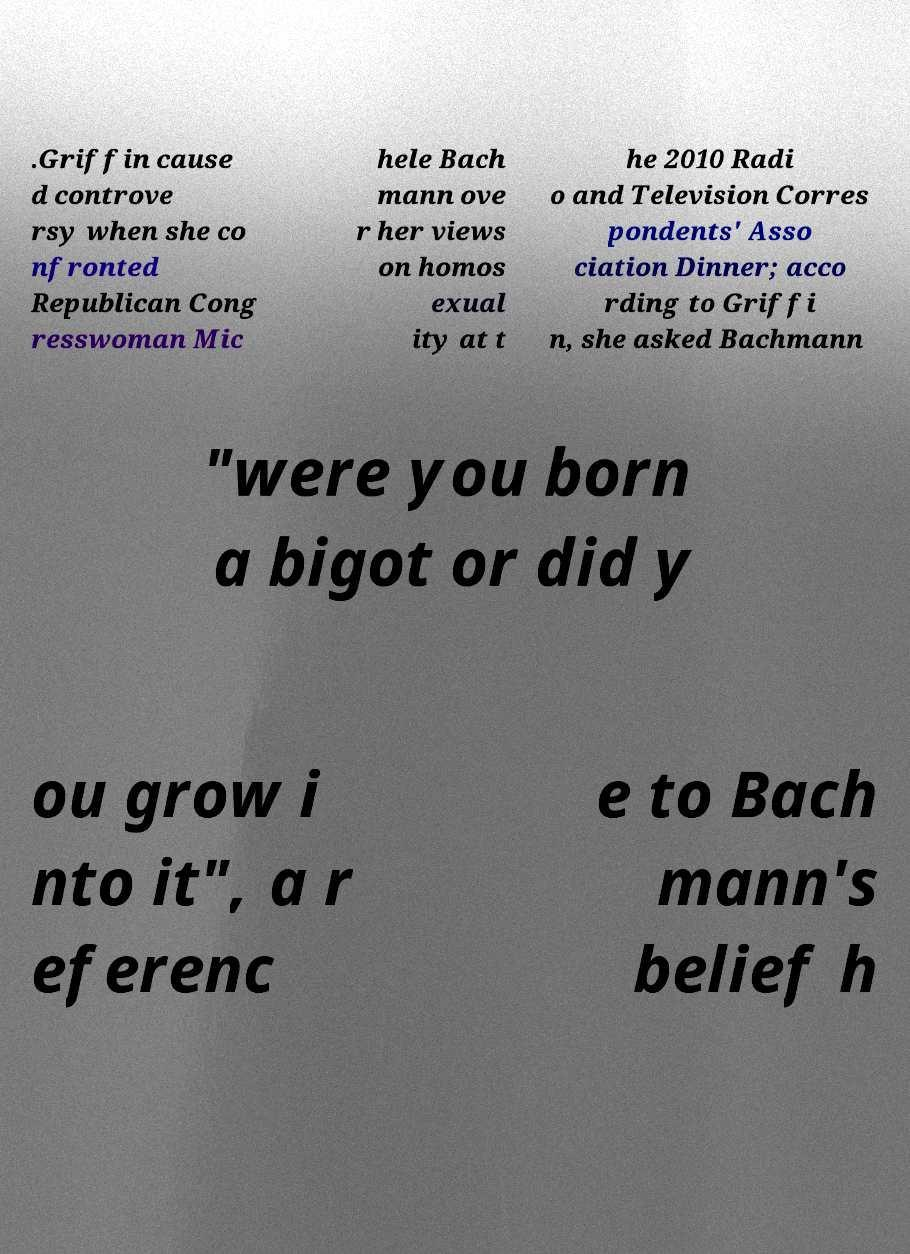What messages or text are displayed in this image? I need them in a readable, typed format. .Griffin cause d controve rsy when she co nfronted Republican Cong resswoman Mic hele Bach mann ove r her views on homos exual ity at t he 2010 Radi o and Television Corres pondents' Asso ciation Dinner; acco rding to Griffi n, she asked Bachmann "were you born a bigot or did y ou grow i nto it", a r eferenc e to Bach mann's belief h 